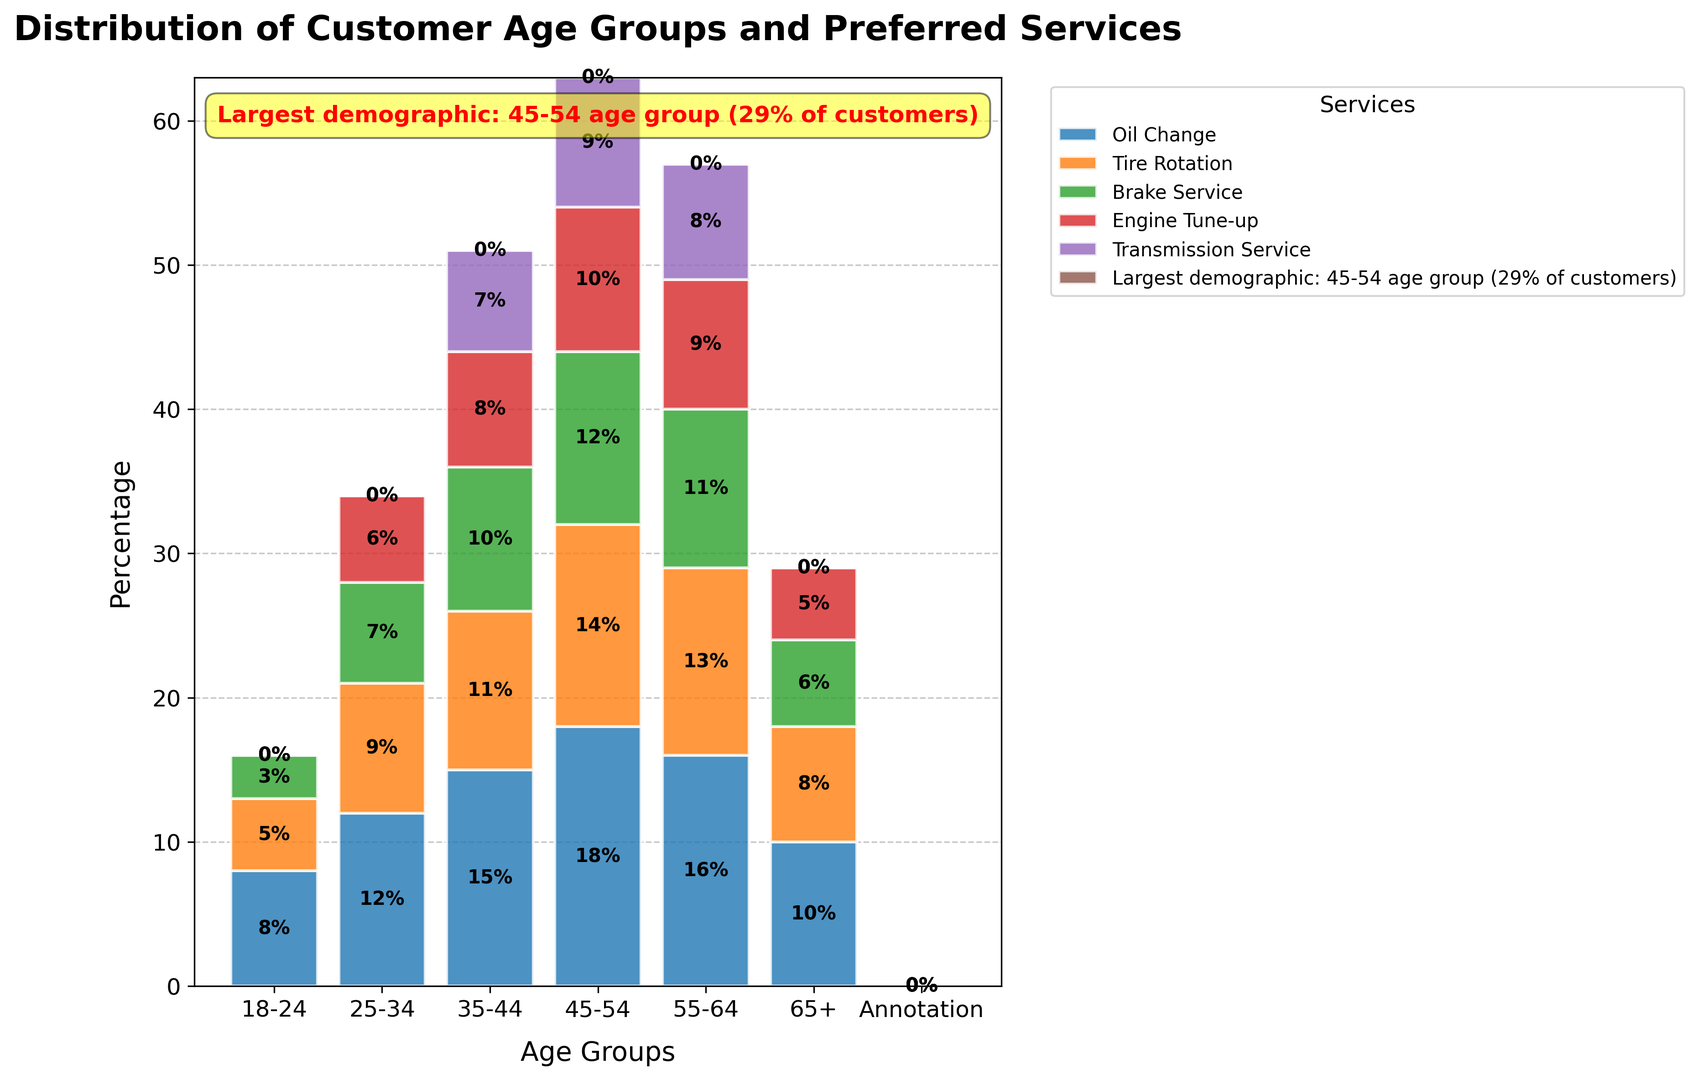What is the largest age group in the chart? The annotation indicates that the largest demographic is the 45-54 age group, which accounts for 29% of customers. This information can be directly inferred from the note.
Answer: The 45-54 age group Which service is the most popular among the 25-34 age group? By looking at the bars clustered under the 25-34 age group section, the Oil Change bar is the tallest, indicating it is the most preferred service at 12%.
Answer: Oil Change What percentage of the 35-44 age group prefers Engine Tune-up? Find the height of the Engine Tune-up bar under the 35-44 age group, which is marked at 8%.
Answer: 8% Compare the preference for Tire Rotation services between the 18-24 and 65+ age groups. Which age group has a higher percentage? The bar for Tire Rotation under the 18-24 age group reaches 5%, while under the 65+ age group, it reaches 8%.
Answer: 65+ age group How much larger is the percentage of 45-54 age group customers compared to the 65+ age group customers according to the annotation? The annotation states that the 45-54 age group accounts for 29% of customers. Considering no specific value is given for the 65+ in the annotation, sum up the percentages for the 65+ reported in the chart (10 + 8 + 6 + 5) which equals 29. The difference is then 29% - 29%, resulting in 0%.
Answer: 0% What is the most popular service overall across all age groups? Analyze all the bars across different age groups to see which service appears the most frequently with the tallest bars. Oil Change repeatedly has the highest percentage across all age groups, making it the most popular.
Answer: Oil Change Which age group has the smallest preference for Brake Service? By examining the Brake Service bars for all age groups, the 18-24 age group has the smallest at 3%.
Answer: 18-24 age group What is the total percentage of customers aged 55-64 who prefer Engine Tune-up and Transmission Service combined? For the 55-64 age group, sum the percentages for Engine Tune-up (9%) and Transmission Service (8%), resulting in 17%.
Answer: 17% Which service has the most equal distribution across all age groups? Compare the height of the bars for each service for different age groups. Tire Rotation seems to have relatively consistent heights (ranging around 5-14%) across all age groups, suggesting an even distribution.
Answer: Tire Rotation 